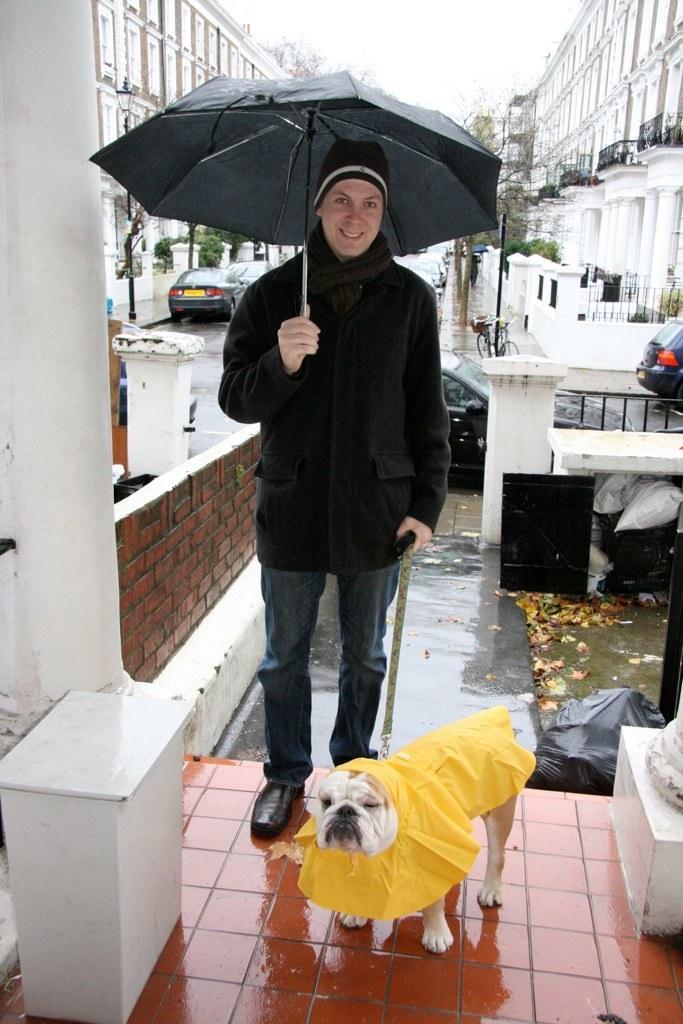Can you describe this image briefly? In this image I can see a person standing and the person is wearing black color dress and the person is holding a black color umbrella. In front I can see a dog which is in white and yellow color. Background I can see few vehicles on the road, buildings in white color, trees in green color and the sky is in white color, 